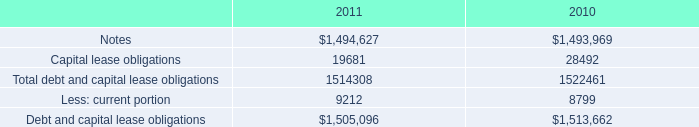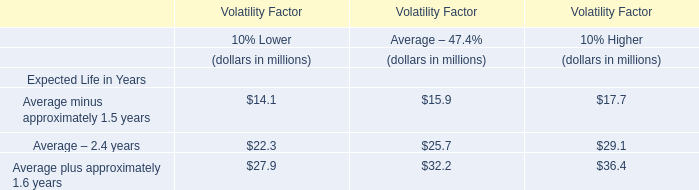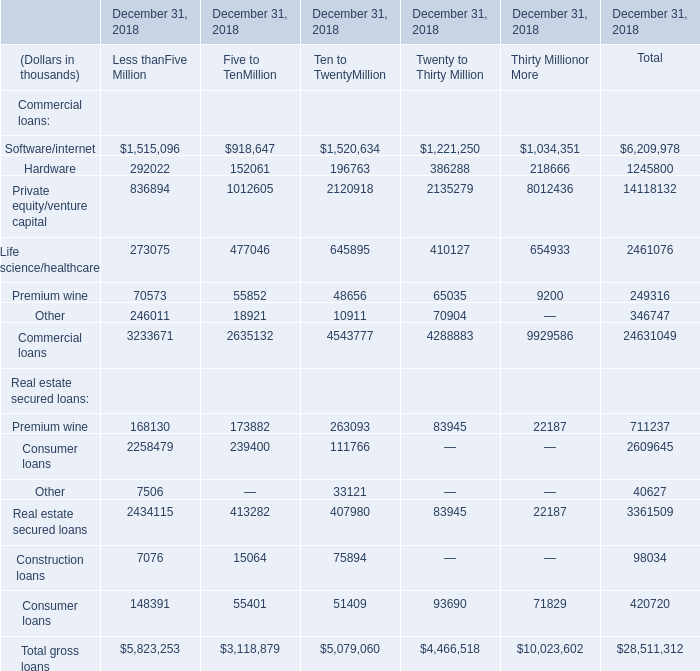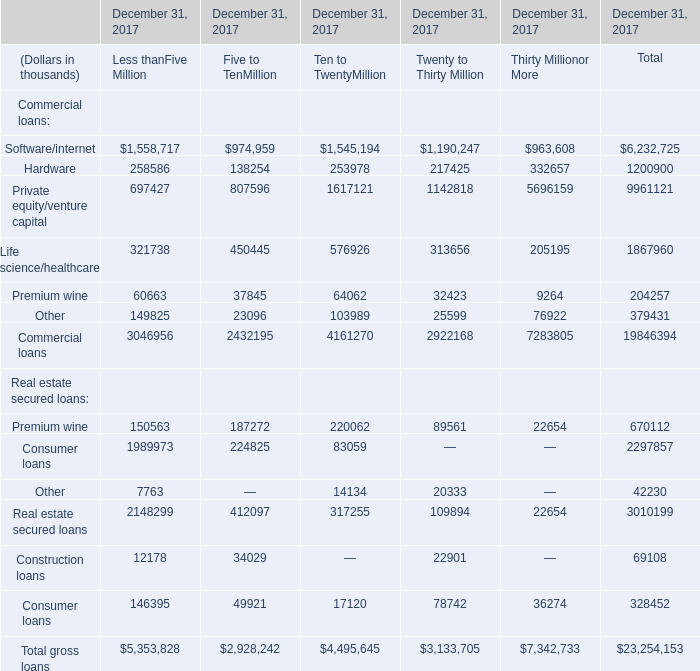What is the sum of Private equity/venture capital of December 31, 2018 Thirty Millionor More, and Private equity/venture capital of December 31, 2017 Thirty Millionor More ? 
Computations: (8012436.0 + 5696159.0)
Answer: 13708595.0. 